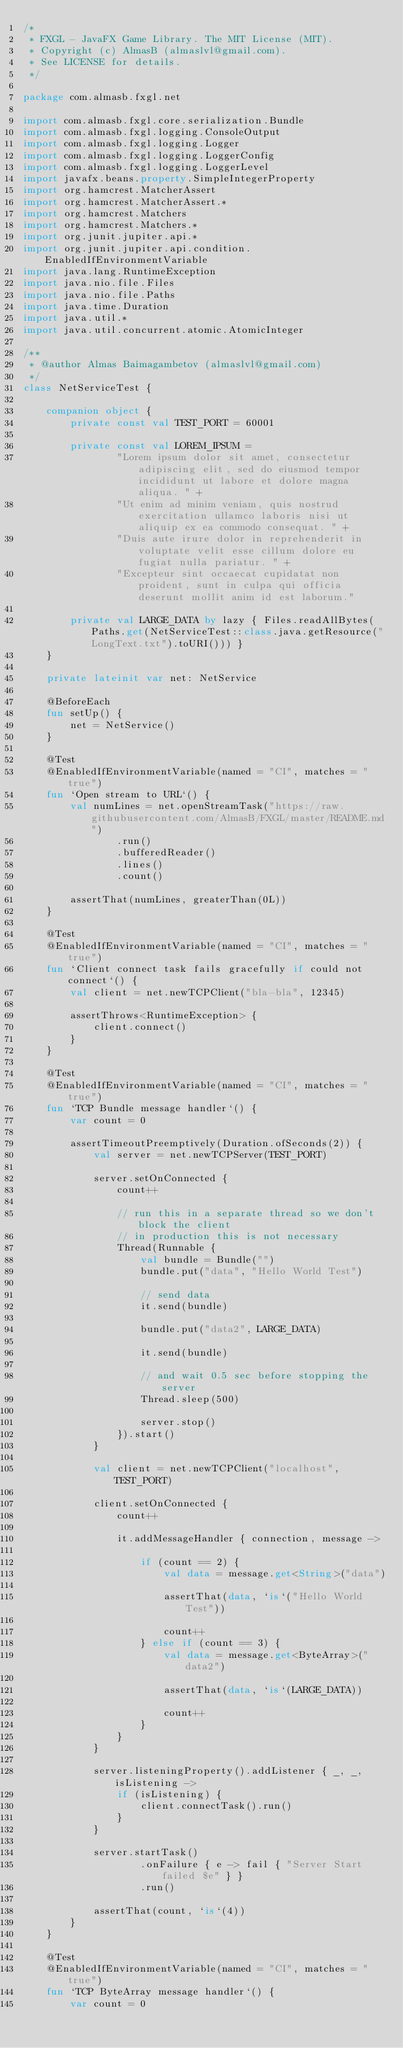<code> <loc_0><loc_0><loc_500><loc_500><_Kotlin_>/*
 * FXGL - JavaFX Game Library. The MIT License (MIT).
 * Copyright (c) AlmasB (almaslvl@gmail.com).
 * See LICENSE for details.
 */

package com.almasb.fxgl.net

import com.almasb.fxgl.core.serialization.Bundle
import com.almasb.fxgl.logging.ConsoleOutput
import com.almasb.fxgl.logging.Logger
import com.almasb.fxgl.logging.LoggerConfig
import com.almasb.fxgl.logging.LoggerLevel
import javafx.beans.property.SimpleIntegerProperty
import org.hamcrest.MatcherAssert
import org.hamcrest.MatcherAssert.*
import org.hamcrest.Matchers
import org.hamcrest.Matchers.*
import org.junit.jupiter.api.*
import org.junit.jupiter.api.condition.EnabledIfEnvironmentVariable
import java.lang.RuntimeException
import java.nio.file.Files
import java.nio.file.Paths
import java.time.Duration
import java.util.*
import java.util.concurrent.atomic.AtomicInteger

/**
 * @author Almas Baimagambetov (almaslvl@gmail.com)
 */
class NetServiceTest {

    companion object {
        private const val TEST_PORT = 60001

        private const val LOREM_IPSUM =
                "Lorem ipsum dolor sit amet, consectetur adipiscing elit, sed do eiusmod tempor incididunt ut labore et dolore magna aliqua. " +
                "Ut enim ad minim veniam, quis nostrud exercitation ullamco laboris nisi ut aliquip ex ea commodo consequat. " +
                "Duis aute irure dolor in reprehenderit in voluptate velit esse cillum dolore eu fugiat nulla pariatur. " +
                "Excepteur sint occaecat cupidatat non proident, sunt in culpa qui officia deserunt mollit anim id est laborum."

        private val LARGE_DATA by lazy { Files.readAllBytes(Paths.get(NetServiceTest::class.java.getResource("LongText.txt").toURI())) }
    }

    private lateinit var net: NetService

    @BeforeEach
    fun setUp() {
        net = NetService()
    }

    @Test
    @EnabledIfEnvironmentVariable(named = "CI", matches = "true")
    fun `Open stream to URL`() {
        val numLines = net.openStreamTask("https://raw.githubusercontent.com/AlmasB/FXGL/master/README.md")
                .run()
                .bufferedReader()
                .lines()
                .count()

        assertThat(numLines, greaterThan(0L))
    }

    @Test
    @EnabledIfEnvironmentVariable(named = "CI", matches = "true")
    fun `Client connect task fails gracefully if could not connect`() {
        val client = net.newTCPClient("bla-bla", 12345)

        assertThrows<RuntimeException> {
            client.connect()
        }
    }

    @Test
    @EnabledIfEnvironmentVariable(named = "CI", matches = "true")
    fun `TCP Bundle message handler`() {
        var count = 0

        assertTimeoutPreemptively(Duration.ofSeconds(2)) {
            val server = net.newTCPServer(TEST_PORT)

            server.setOnConnected {
                count++

                // run this in a separate thread so we don't block the client
                // in production this is not necessary
                Thread(Runnable {
                    val bundle = Bundle("")
                    bundle.put("data", "Hello World Test")

                    // send data
                    it.send(bundle)

                    bundle.put("data2", LARGE_DATA)

                    it.send(bundle)

                    // and wait 0.5 sec before stopping the server
                    Thread.sleep(500)

                    server.stop()
                }).start()
            }

            val client = net.newTCPClient("localhost", TEST_PORT)

            client.setOnConnected {
                count++

                it.addMessageHandler { connection, message ->

                    if (count == 2) {
                        val data = message.get<String>("data")

                        assertThat(data, `is`("Hello World Test"))

                        count++
                    } else if (count == 3) {
                        val data = message.get<ByteArray>("data2")

                        assertThat(data, `is`(LARGE_DATA))

                        count++
                    }
                }
            }

            server.listeningProperty().addListener { _, _, isListening ->
                if (isListening) {
                    client.connectTask().run()
                }
            }

            server.startTask()
                    .onFailure { e -> fail { "Server Start failed $e" } }
                    .run()

            assertThat(count, `is`(4))
        }
    }

    @Test
    @EnabledIfEnvironmentVariable(named = "CI", matches = "true")
    fun `TCP ByteArray message handler`() {
        var count = 0
</code> 